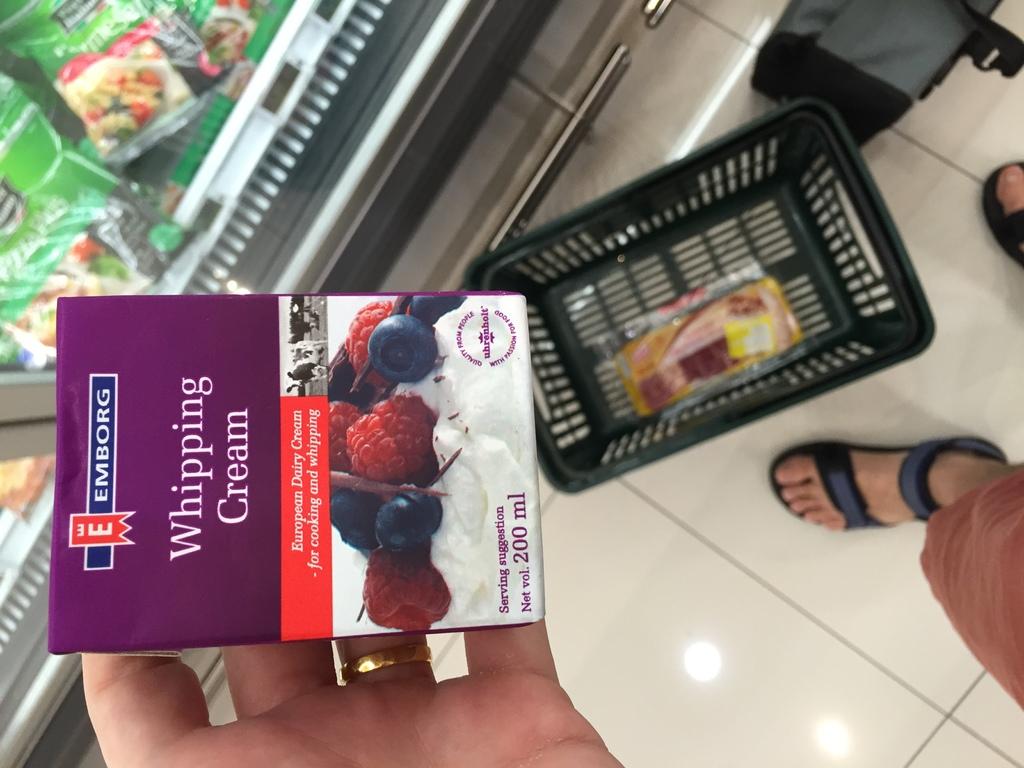How many ml of whipping cream does this box contain?
Provide a short and direct response. 200. 